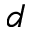Convert formula to latex. <formula><loc_0><loc_0><loc_500><loc_500>d</formula> 